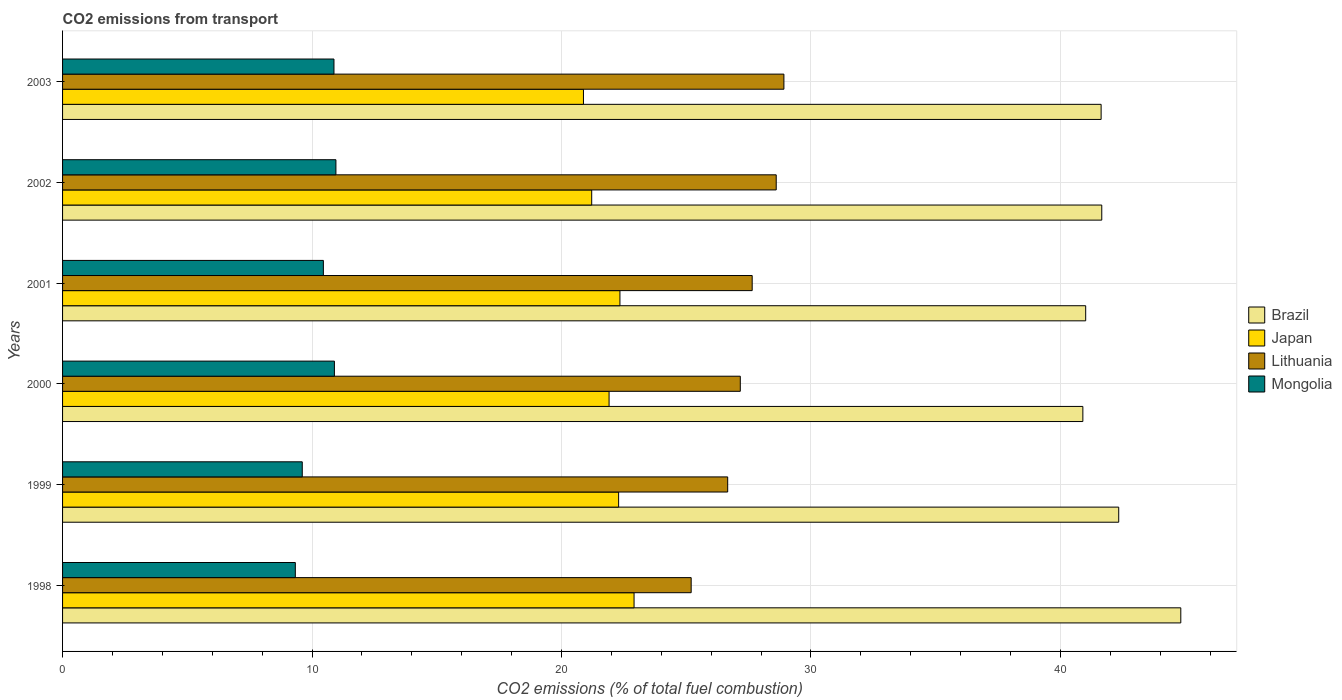How many bars are there on the 6th tick from the bottom?
Provide a short and direct response. 4. What is the total CO2 emitted in Japan in 2001?
Your response must be concise. 22.34. Across all years, what is the maximum total CO2 emitted in Brazil?
Ensure brevity in your answer.  44.82. Across all years, what is the minimum total CO2 emitted in Japan?
Offer a very short reply. 20.88. In which year was the total CO2 emitted in Brazil maximum?
Offer a very short reply. 1998. In which year was the total CO2 emitted in Japan minimum?
Make the answer very short. 2003. What is the total total CO2 emitted in Lithuania in the graph?
Provide a succinct answer. 164.19. What is the difference between the total CO2 emitted in Japan in 2000 and that in 2001?
Offer a very short reply. -0.44. What is the difference between the total CO2 emitted in Brazil in 2000 and the total CO2 emitted in Japan in 1999?
Offer a very short reply. 18.61. What is the average total CO2 emitted in Lithuania per year?
Ensure brevity in your answer.  27.37. In the year 1999, what is the difference between the total CO2 emitted in Mongolia and total CO2 emitted in Japan?
Ensure brevity in your answer.  -12.68. What is the ratio of the total CO2 emitted in Brazil in 1998 to that in 2000?
Provide a short and direct response. 1.1. Is the total CO2 emitted in Japan in 2000 less than that in 2002?
Ensure brevity in your answer.  No. What is the difference between the highest and the second highest total CO2 emitted in Lithuania?
Ensure brevity in your answer.  0.31. What is the difference between the highest and the lowest total CO2 emitted in Japan?
Your response must be concise. 2.03. In how many years, is the total CO2 emitted in Lithuania greater than the average total CO2 emitted in Lithuania taken over all years?
Your answer should be compact. 3. What does the 3rd bar from the top in 2003 represents?
Offer a very short reply. Japan. What does the 2nd bar from the bottom in 2003 represents?
Offer a very short reply. Japan. Is it the case that in every year, the sum of the total CO2 emitted in Lithuania and total CO2 emitted in Japan is greater than the total CO2 emitted in Mongolia?
Your response must be concise. Yes. Are the values on the major ticks of X-axis written in scientific E-notation?
Your answer should be compact. No. Where does the legend appear in the graph?
Your response must be concise. Center right. How are the legend labels stacked?
Your answer should be very brief. Vertical. What is the title of the graph?
Provide a succinct answer. CO2 emissions from transport. What is the label or title of the X-axis?
Your answer should be very brief. CO2 emissions (% of total fuel combustion). What is the CO2 emissions (% of total fuel combustion) of Brazil in 1998?
Your response must be concise. 44.82. What is the CO2 emissions (% of total fuel combustion) in Japan in 1998?
Your response must be concise. 22.91. What is the CO2 emissions (% of total fuel combustion) in Lithuania in 1998?
Your response must be concise. 25.2. What is the CO2 emissions (% of total fuel combustion) of Mongolia in 1998?
Your response must be concise. 9.33. What is the CO2 emissions (% of total fuel combustion) of Brazil in 1999?
Your response must be concise. 42.34. What is the CO2 emissions (% of total fuel combustion) of Japan in 1999?
Your answer should be compact. 22.29. What is the CO2 emissions (% of total fuel combustion) in Lithuania in 1999?
Your answer should be very brief. 26.66. What is the CO2 emissions (% of total fuel combustion) of Mongolia in 1999?
Make the answer very short. 9.61. What is the CO2 emissions (% of total fuel combustion) of Brazil in 2000?
Make the answer very short. 40.9. What is the CO2 emissions (% of total fuel combustion) in Japan in 2000?
Provide a succinct answer. 21.91. What is the CO2 emissions (% of total fuel combustion) in Lithuania in 2000?
Your answer should be very brief. 27.17. What is the CO2 emissions (% of total fuel combustion) of Mongolia in 2000?
Ensure brevity in your answer.  10.9. What is the CO2 emissions (% of total fuel combustion) of Brazil in 2001?
Provide a succinct answer. 41.01. What is the CO2 emissions (% of total fuel combustion) of Japan in 2001?
Your answer should be compact. 22.34. What is the CO2 emissions (% of total fuel combustion) of Lithuania in 2001?
Provide a succinct answer. 27.64. What is the CO2 emissions (% of total fuel combustion) of Mongolia in 2001?
Offer a terse response. 10.45. What is the CO2 emissions (% of total fuel combustion) in Brazil in 2002?
Your response must be concise. 41.66. What is the CO2 emissions (% of total fuel combustion) in Japan in 2002?
Your response must be concise. 21.21. What is the CO2 emissions (% of total fuel combustion) of Lithuania in 2002?
Your answer should be compact. 28.61. What is the CO2 emissions (% of total fuel combustion) in Mongolia in 2002?
Give a very brief answer. 10.96. What is the CO2 emissions (% of total fuel combustion) of Brazil in 2003?
Provide a succinct answer. 41.63. What is the CO2 emissions (% of total fuel combustion) in Japan in 2003?
Keep it short and to the point. 20.88. What is the CO2 emissions (% of total fuel combustion) of Lithuania in 2003?
Provide a succinct answer. 28.91. What is the CO2 emissions (% of total fuel combustion) of Mongolia in 2003?
Give a very brief answer. 10.88. Across all years, what is the maximum CO2 emissions (% of total fuel combustion) of Brazil?
Your response must be concise. 44.82. Across all years, what is the maximum CO2 emissions (% of total fuel combustion) of Japan?
Make the answer very short. 22.91. Across all years, what is the maximum CO2 emissions (% of total fuel combustion) of Lithuania?
Provide a short and direct response. 28.91. Across all years, what is the maximum CO2 emissions (% of total fuel combustion) of Mongolia?
Ensure brevity in your answer.  10.96. Across all years, what is the minimum CO2 emissions (% of total fuel combustion) in Brazil?
Offer a very short reply. 40.9. Across all years, what is the minimum CO2 emissions (% of total fuel combustion) of Japan?
Provide a succinct answer. 20.88. Across all years, what is the minimum CO2 emissions (% of total fuel combustion) in Lithuania?
Make the answer very short. 25.2. Across all years, what is the minimum CO2 emissions (% of total fuel combustion) in Mongolia?
Provide a succinct answer. 9.33. What is the total CO2 emissions (% of total fuel combustion) in Brazil in the graph?
Keep it short and to the point. 252.36. What is the total CO2 emissions (% of total fuel combustion) in Japan in the graph?
Make the answer very short. 131.54. What is the total CO2 emissions (% of total fuel combustion) in Lithuania in the graph?
Make the answer very short. 164.19. What is the total CO2 emissions (% of total fuel combustion) in Mongolia in the graph?
Ensure brevity in your answer.  62.13. What is the difference between the CO2 emissions (% of total fuel combustion) in Brazil in 1998 and that in 1999?
Make the answer very short. 2.49. What is the difference between the CO2 emissions (% of total fuel combustion) of Japan in 1998 and that in 1999?
Your answer should be compact. 0.62. What is the difference between the CO2 emissions (% of total fuel combustion) of Lithuania in 1998 and that in 1999?
Keep it short and to the point. -1.46. What is the difference between the CO2 emissions (% of total fuel combustion) in Mongolia in 1998 and that in 1999?
Give a very brief answer. -0.28. What is the difference between the CO2 emissions (% of total fuel combustion) in Brazil in 1998 and that in 2000?
Keep it short and to the point. 3.93. What is the difference between the CO2 emissions (% of total fuel combustion) in Japan in 1998 and that in 2000?
Ensure brevity in your answer.  1. What is the difference between the CO2 emissions (% of total fuel combustion) of Lithuania in 1998 and that in 2000?
Your answer should be very brief. -1.97. What is the difference between the CO2 emissions (% of total fuel combustion) of Mongolia in 1998 and that in 2000?
Ensure brevity in your answer.  -1.57. What is the difference between the CO2 emissions (% of total fuel combustion) in Brazil in 1998 and that in 2001?
Make the answer very short. 3.81. What is the difference between the CO2 emissions (% of total fuel combustion) of Japan in 1998 and that in 2001?
Keep it short and to the point. 0.57. What is the difference between the CO2 emissions (% of total fuel combustion) in Lithuania in 1998 and that in 2001?
Provide a short and direct response. -2.45. What is the difference between the CO2 emissions (% of total fuel combustion) of Mongolia in 1998 and that in 2001?
Provide a succinct answer. -1.12. What is the difference between the CO2 emissions (% of total fuel combustion) in Brazil in 1998 and that in 2002?
Your response must be concise. 3.17. What is the difference between the CO2 emissions (% of total fuel combustion) in Japan in 1998 and that in 2002?
Offer a terse response. 1.7. What is the difference between the CO2 emissions (% of total fuel combustion) in Lithuania in 1998 and that in 2002?
Keep it short and to the point. -3.41. What is the difference between the CO2 emissions (% of total fuel combustion) of Mongolia in 1998 and that in 2002?
Keep it short and to the point. -1.63. What is the difference between the CO2 emissions (% of total fuel combustion) in Brazil in 1998 and that in 2003?
Provide a succinct answer. 3.19. What is the difference between the CO2 emissions (% of total fuel combustion) in Japan in 1998 and that in 2003?
Provide a succinct answer. 2.03. What is the difference between the CO2 emissions (% of total fuel combustion) in Lithuania in 1998 and that in 2003?
Make the answer very short. -3.72. What is the difference between the CO2 emissions (% of total fuel combustion) in Mongolia in 1998 and that in 2003?
Offer a very short reply. -1.55. What is the difference between the CO2 emissions (% of total fuel combustion) of Brazil in 1999 and that in 2000?
Offer a terse response. 1.44. What is the difference between the CO2 emissions (% of total fuel combustion) of Japan in 1999 and that in 2000?
Keep it short and to the point. 0.38. What is the difference between the CO2 emissions (% of total fuel combustion) in Lithuania in 1999 and that in 2000?
Make the answer very short. -0.51. What is the difference between the CO2 emissions (% of total fuel combustion) of Mongolia in 1999 and that in 2000?
Provide a short and direct response. -1.29. What is the difference between the CO2 emissions (% of total fuel combustion) in Brazil in 1999 and that in 2001?
Provide a short and direct response. 1.32. What is the difference between the CO2 emissions (% of total fuel combustion) in Japan in 1999 and that in 2001?
Make the answer very short. -0.05. What is the difference between the CO2 emissions (% of total fuel combustion) in Lithuania in 1999 and that in 2001?
Provide a succinct answer. -0.98. What is the difference between the CO2 emissions (% of total fuel combustion) of Mongolia in 1999 and that in 2001?
Keep it short and to the point. -0.85. What is the difference between the CO2 emissions (% of total fuel combustion) in Brazil in 1999 and that in 2002?
Your answer should be very brief. 0.68. What is the difference between the CO2 emissions (% of total fuel combustion) of Japan in 1999 and that in 2002?
Your response must be concise. 1.08. What is the difference between the CO2 emissions (% of total fuel combustion) of Lithuania in 1999 and that in 2002?
Ensure brevity in your answer.  -1.95. What is the difference between the CO2 emissions (% of total fuel combustion) of Mongolia in 1999 and that in 2002?
Your response must be concise. -1.35. What is the difference between the CO2 emissions (% of total fuel combustion) in Brazil in 1999 and that in 2003?
Your answer should be very brief. 0.71. What is the difference between the CO2 emissions (% of total fuel combustion) in Japan in 1999 and that in 2003?
Provide a short and direct response. 1.41. What is the difference between the CO2 emissions (% of total fuel combustion) of Lithuania in 1999 and that in 2003?
Keep it short and to the point. -2.25. What is the difference between the CO2 emissions (% of total fuel combustion) in Mongolia in 1999 and that in 2003?
Keep it short and to the point. -1.27. What is the difference between the CO2 emissions (% of total fuel combustion) of Brazil in 2000 and that in 2001?
Provide a short and direct response. -0.11. What is the difference between the CO2 emissions (% of total fuel combustion) in Japan in 2000 and that in 2001?
Give a very brief answer. -0.44. What is the difference between the CO2 emissions (% of total fuel combustion) of Lithuania in 2000 and that in 2001?
Your answer should be very brief. -0.48. What is the difference between the CO2 emissions (% of total fuel combustion) of Mongolia in 2000 and that in 2001?
Provide a short and direct response. 0.44. What is the difference between the CO2 emissions (% of total fuel combustion) of Brazil in 2000 and that in 2002?
Offer a very short reply. -0.76. What is the difference between the CO2 emissions (% of total fuel combustion) of Japan in 2000 and that in 2002?
Offer a very short reply. 0.7. What is the difference between the CO2 emissions (% of total fuel combustion) of Lithuania in 2000 and that in 2002?
Your answer should be compact. -1.44. What is the difference between the CO2 emissions (% of total fuel combustion) in Mongolia in 2000 and that in 2002?
Provide a short and direct response. -0.06. What is the difference between the CO2 emissions (% of total fuel combustion) of Brazil in 2000 and that in 2003?
Offer a very short reply. -0.73. What is the difference between the CO2 emissions (% of total fuel combustion) of Lithuania in 2000 and that in 2003?
Provide a short and direct response. -1.75. What is the difference between the CO2 emissions (% of total fuel combustion) of Mongolia in 2000 and that in 2003?
Ensure brevity in your answer.  0.02. What is the difference between the CO2 emissions (% of total fuel combustion) of Brazil in 2001 and that in 2002?
Keep it short and to the point. -0.64. What is the difference between the CO2 emissions (% of total fuel combustion) of Japan in 2001 and that in 2002?
Your answer should be very brief. 1.13. What is the difference between the CO2 emissions (% of total fuel combustion) of Lithuania in 2001 and that in 2002?
Your answer should be very brief. -0.96. What is the difference between the CO2 emissions (% of total fuel combustion) of Mongolia in 2001 and that in 2002?
Offer a very short reply. -0.5. What is the difference between the CO2 emissions (% of total fuel combustion) of Brazil in 2001 and that in 2003?
Offer a terse response. -0.62. What is the difference between the CO2 emissions (% of total fuel combustion) in Japan in 2001 and that in 2003?
Offer a very short reply. 1.46. What is the difference between the CO2 emissions (% of total fuel combustion) of Lithuania in 2001 and that in 2003?
Your answer should be very brief. -1.27. What is the difference between the CO2 emissions (% of total fuel combustion) in Mongolia in 2001 and that in 2003?
Keep it short and to the point. -0.42. What is the difference between the CO2 emissions (% of total fuel combustion) of Brazil in 2002 and that in 2003?
Provide a succinct answer. 0.03. What is the difference between the CO2 emissions (% of total fuel combustion) in Japan in 2002 and that in 2003?
Your answer should be very brief. 0.33. What is the difference between the CO2 emissions (% of total fuel combustion) in Lithuania in 2002 and that in 2003?
Offer a very short reply. -0.31. What is the difference between the CO2 emissions (% of total fuel combustion) of Mongolia in 2002 and that in 2003?
Offer a terse response. 0.08. What is the difference between the CO2 emissions (% of total fuel combustion) in Brazil in 1998 and the CO2 emissions (% of total fuel combustion) in Japan in 1999?
Make the answer very short. 22.53. What is the difference between the CO2 emissions (% of total fuel combustion) of Brazil in 1998 and the CO2 emissions (% of total fuel combustion) of Lithuania in 1999?
Offer a very short reply. 18.16. What is the difference between the CO2 emissions (% of total fuel combustion) in Brazil in 1998 and the CO2 emissions (% of total fuel combustion) in Mongolia in 1999?
Ensure brevity in your answer.  35.22. What is the difference between the CO2 emissions (% of total fuel combustion) of Japan in 1998 and the CO2 emissions (% of total fuel combustion) of Lithuania in 1999?
Your answer should be very brief. -3.75. What is the difference between the CO2 emissions (% of total fuel combustion) of Japan in 1998 and the CO2 emissions (% of total fuel combustion) of Mongolia in 1999?
Offer a very short reply. 13.3. What is the difference between the CO2 emissions (% of total fuel combustion) of Lithuania in 1998 and the CO2 emissions (% of total fuel combustion) of Mongolia in 1999?
Ensure brevity in your answer.  15.59. What is the difference between the CO2 emissions (% of total fuel combustion) of Brazil in 1998 and the CO2 emissions (% of total fuel combustion) of Japan in 2000?
Give a very brief answer. 22.92. What is the difference between the CO2 emissions (% of total fuel combustion) in Brazil in 1998 and the CO2 emissions (% of total fuel combustion) in Lithuania in 2000?
Make the answer very short. 17.66. What is the difference between the CO2 emissions (% of total fuel combustion) in Brazil in 1998 and the CO2 emissions (% of total fuel combustion) in Mongolia in 2000?
Ensure brevity in your answer.  33.93. What is the difference between the CO2 emissions (% of total fuel combustion) of Japan in 1998 and the CO2 emissions (% of total fuel combustion) of Lithuania in 2000?
Your response must be concise. -4.26. What is the difference between the CO2 emissions (% of total fuel combustion) in Japan in 1998 and the CO2 emissions (% of total fuel combustion) in Mongolia in 2000?
Your answer should be compact. 12.01. What is the difference between the CO2 emissions (% of total fuel combustion) in Lithuania in 1998 and the CO2 emissions (% of total fuel combustion) in Mongolia in 2000?
Offer a very short reply. 14.3. What is the difference between the CO2 emissions (% of total fuel combustion) in Brazil in 1998 and the CO2 emissions (% of total fuel combustion) in Japan in 2001?
Ensure brevity in your answer.  22.48. What is the difference between the CO2 emissions (% of total fuel combustion) in Brazil in 1998 and the CO2 emissions (% of total fuel combustion) in Lithuania in 2001?
Keep it short and to the point. 17.18. What is the difference between the CO2 emissions (% of total fuel combustion) of Brazil in 1998 and the CO2 emissions (% of total fuel combustion) of Mongolia in 2001?
Provide a short and direct response. 34.37. What is the difference between the CO2 emissions (% of total fuel combustion) of Japan in 1998 and the CO2 emissions (% of total fuel combustion) of Lithuania in 2001?
Make the answer very short. -4.73. What is the difference between the CO2 emissions (% of total fuel combustion) of Japan in 1998 and the CO2 emissions (% of total fuel combustion) of Mongolia in 2001?
Provide a succinct answer. 12.45. What is the difference between the CO2 emissions (% of total fuel combustion) in Lithuania in 1998 and the CO2 emissions (% of total fuel combustion) in Mongolia in 2001?
Give a very brief answer. 14.74. What is the difference between the CO2 emissions (% of total fuel combustion) in Brazil in 1998 and the CO2 emissions (% of total fuel combustion) in Japan in 2002?
Your response must be concise. 23.61. What is the difference between the CO2 emissions (% of total fuel combustion) of Brazil in 1998 and the CO2 emissions (% of total fuel combustion) of Lithuania in 2002?
Your answer should be very brief. 16.22. What is the difference between the CO2 emissions (% of total fuel combustion) in Brazil in 1998 and the CO2 emissions (% of total fuel combustion) in Mongolia in 2002?
Offer a very short reply. 33.87. What is the difference between the CO2 emissions (% of total fuel combustion) of Japan in 1998 and the CO2 emissions (% of total fuel combustion) of Lithuania in 2002?
Your answer should be compact. -5.7. What is the difference between the CO2 emissions (% of total fuel combustion) in Japan in 1998 and the CO2 emissions (% of total fuel combustion) in Mongolia in 2002?
Provide a short and direct response. 11.95. What is the difference between the CO2 emissions (% of total fuel combustion) of Lithuania in 1998 and the CO2 emissions (% of total fuel combustion) of Mongolia in 2002?
Give a very brief answer. 14.24. What is the difference between the CO2 emissions (% of total fuel combustion) of Brazil in 1998 and the CO2 emissions (% of total fuel combustion) of Japan in 2003?
Provide a succinct answer. 23.94. What is the difference between the CO2 emissions (% of total fuel combustion) of Brazil in 1998 and the CO2 emissions (% of total fuel combustion) of Lithuania in 2003?
Keep it short and to the point. 15.91. What is the difference between the CO2 emissions (% of total fuel combustion) in Brazil in 1998 and the CO2 emissions (% of total fuel combustion) in Mongolia in 2003?
Ensure brevity in your answer.  33.95. What is the difference between the CO2 emissions (% of total fuel combustion) of Japan in 1998 and the CO2 emissions (% of total fuel combustion) of Lithuania in 2003?
Your response must be concise. -6.01. What is the difference between the CO2 emissions (% of total fuel combustion) of Japan in 1998 and the CO2 emissions (% of total fuel combustion) of Mongolia in 2003?
Offer a terse response. 12.03. What is the difference between the CO2 emissions (% of total fuel combustion) of Lithuania in 1998 and the CO2 emissions (% of total fuel combustion) of Mongolia in 2003?
Ensure brevity in your answer.  14.32. What is the difference between the CO2 emissions (% of total fuel combustion) in Brazil in 1999 and the CO2 emissions (% of total fuel combustion) in Japan in 2000?
Your answer should be very brief. 20.43. What is the difference between the CO2 emissions (% of total fuel combustion) of Brazil in 1999 and the CO2 emissions (% of total fuel combustion) of Lithuania in 2000?
Provide a short and direct response. 15.17. What is the difference between the CO2 emissions (% of total fuel combustion) of Brazil in 1999 and the CO2 emissions (% of total fuel combustion) of Mongolia in 2000?
Give a very brief answer. 31.44. What is the difference between the CO2 emissions (% of total fuel combustion) of Japan in 1999 and the CO2 emissions (% of total fuel combustion) of Lithuania in 2000?
Ensure brevity in your answer.  -4.88. What is the difference between the CO2 emissions (% of total fuel combustion) of Japan in 1999 and the CO2 emissions (% of total fuel combustion) of Mongolia in 2000?
Your answer should be very brief. 11.39. What is the difference between the CO2 emissions (% of total fuel combustion) of Lithuania in 1999 and the CO2 emissions (% of total fuel combustion) of Mongolia in 2000?
Keep it short and to the point. 15.76. What is the difference between the CO2 emissions (% of total fuel combustion) in Brazil in 1999 and the CO2 emissions (% of total fuel combustion) in Japan in 2001?
Provide a succinct answer. 19.99. What is the difference between the CO2 emissions (% of total fuel combustion) of Brazil in 1999 and the CO2 emissions (% of total fuel combustion) of Lithuania in 2001?
Provide a short and direct response. 14.69. What is the difference between the CO2 emissions (% of total fuel combustion) of Brazil in 1999 and the CO2 emissions (% of total fuel combustion) of Mongolia in 2001?
Offer a very short reply. 31.88. What is the difference between the CO2 emissions (% of total fuel combustion) in Japan in 1999 and the CO2 emissions (% of total fuel combustion) in Lithuania in 2001?
Provide a succinct answer. -5.35. What is the difference between the CO2 emissions (% of total fuel combustion) in Japan in 1999 and the CO2 emissions (% of total fuel combustion) in Mongolia in 2001?
Make the answer very short. 11.84. What is the difference between the CO2 emissions (% of total fuel combustion) of Lithuania in 1999 and the CO2 emissions (% of total fuel combustion) of Mongolia in 2001?
Keep it short and to the point. 16.21. What is the difference between the CO2 emissions (% of total fuel combustion) of Brazil in 1999 and the CO2 emissions (% of total fuel combustion) of Japan in 2002?
Offer a terse response. 21.13. What is the difference between the CO2 emissions (% of total fuel combustion) of Brazil in 1999 and the CO2 emissions (% of total fuel combustion) of Lithuania in 2002?
Keep it short and to the point. 13.73. What is the difference between the CO2 emissions (% of total fuel combustion) of Brazil in 1999 and the CO2 emissions (% of total fuel combustion) of Mongolia in 2002?
Your response must be concise. 31.38. What is the difference between the CO2 emissions (% of total fuel combustion) of Japan in 1999 and the CO2 emissions (% of total fuel combustion) of Lithuania in 2002?
Your response must be concise. -6.32. What is the difference between the CO2 emissions (% of total fuel combustion) in Japan in 1999 and the CO2 emissions (% of total fuel combustion) in Mongolia in 2002?
Your answer should be very brief. 11.33. What is the difference between the CO2 emissions (% of total fuel combustion) of Lithuania in 1999 and the CO2 emissions (% of total fuel combustion) of Mongolia in 2002?
Make the answer very short. 15.7. What is the difference between the CO2 emissions (% of total fuel combustion) in Brazil in 1999 and the CO2 emissions (% of total fuel combustion) in Japan in 2003?
Your answer should be compact. 21.46. What is the difference between the CO2 emissions (% of total fuel combustion) of Brazil in 1999 and the CO2 emissions (% of total fuel combustion) of Lithuania in 2003?
Keep it short and to the point. 13.42. What is the difference between the CO2 emissions (% of total fuel combustion) of Brazil in 1999 and the CO2 emissions (% of total fuel combustion) of Mongolia in 2003?
Offer a very short reply. 31.46. What is the difference between the CO2 emissions (% of total fuel combustion) of Japan in 1999 and the CO2 emissions (% of total fuel combustion) of Lithuania in 2003?
Give a very brief answer. -6.63. What is the difference between the CO2 emissions (% of total fuel combustion) in Japan in 1999 and the CO2 emissions (% of total fuel combustion) in Mongolia in 2003?
Your answer should be very brief. 11.41. What is the difference between the CO2 emissions (% of total fuel combustion) in Lithuania in 1999 and the CO2 emissions (% of total fuel combustion) in Mongolia in 2003?
Give a very brief answer. 15.78. What is the difference between the CO2 emissions (% of total fuel combustion) in Brazil in 2000 and the CO2 emissions (% of total fuel combustion) in Japan in 2001?
Provide a short and direct response. 18.56. What is the difference between the CO2 emissions (% of total fuel combustion) in Brazil in 2000 and the CO2 emissions (% of total fuel combustion) in Lithuania in 2001?
Keep it short and to the point. 13.26. What is the difference between the CO2 emissions (% of total fuel combustion) in Brazil in 2000 and the CO2 emissions (% of total fuel combustion) in Mongolia in 2001?
Provide a succinct answer. 30.44. What is the difference between the CO2 emissions (% of total fuel combustion) of Japan in 2000 and the CO2 emissions (% of total fuel combustion) of Lithuania in 2001?
Give a very brief answer. -5.74. What is the difference between the CO2 emissions (% of total fuel combustion) of Japan in 2000 and the CO2 emissions (% of total fuel combustion) of Mongolia in 2001?
Your answer should be very brief. 11.45. What is the difference between the CO2 emissions (% of total fuel combustion) in Lithuania in 2000 and the CO2 emissions (% of total fuel combustion) in Mongolia in 2001?
Make the answer very short. 16.71. What is the difference between the CO2 emissions (% of total fuel combustion) of Brazil in 2000 and the CO2 emissions (% of total fuel combustion) of Japan in 2002?
Offer a very short reply. 19.69. What is the difference between the CO2 emissions (% of total fuel combustion) in Brazil in 2000 and the CO2 emissions (% of total fuel combustion) in Lithuania in 2002?
Give a very brief answer. 12.29. What is the difference between the CO2 emissions (% of total fuel combustion) of Brazil in 2000 and the CO2 emissions (% of total fuel combustion) of Mongolia in 2002?
Keep it short and to the point. 29.94. What is the difference between the CO2 emissions (% of total fuel combustion) in Japan in 2000 and the CO2 emissions (% of total fuel combustion) in Lithuania in 2002?
Provide a succinct answer. -6.7. What is the difference between the CO2 emissions (% of total fuel combustion) of Japan in 2000 and the CO2 emissions (% of total fuel combustion) of Mongolia in 2002?
Offer a terse response. 10.95. What is the difference between the CO2 emissions (% of total fuel combustion) in Lithuania in 2000 and the CO2 emissions (% of total fuel combustion) in Mongolia in 2002?
Give a very brief answer. 16.21. What is the difference between the CO2 emissions (% of total fuel combustion) in Brazil in 2000 and the CO2 emissions (% of total fuel combustion) in Japan in 2003?
Offer a very short reply. 20.02. What is the difference between the CO2 emissions (% of total fuel combustion) in Brazil in 2000 and the CO2 emissions (% of total fuel combustion) in Lithuania in 2003?
Offer a terse response. 11.98. What is the difference between the CO2 emissions (% of total fuel combustion) of Brazil in 2000 and the CO2 emissions (% of total fuel combustion) of Mongolia in 2003?
Offer a terse response. 30.02. What is the difference between the CO2 emissions (% of total fuel combustion) in Japan in 2000 and the CO2 emissions (% of total fuel combustion) in Lithuania in 2003?
Keep it short and to the point. -7.01. What is the difference between the CO2 emissions (% of total fuel combustion) of Japan in 2000 and the CO2 emissions (% of total fuel combustion) of Mongolia in 2003?
Ensure brevity in your answer.  11.03. What is the difference between the CO2 emissions (% of total fuel combustion) of Lithuania in 2000 and the CO2 emissions (% of total fuel combustion) of Mongolia in 2003?
Keep it short and to the point. 16.29. What is the difference between the CO2 emissions (% of total fuel combustion) in Brazil in 2001 and the CO2 emissions (% of total fuel combustion) in Japan in 2002?
Offer a terse response. 19.8. What is the difference between the CO2 emissions (% of total fuel combustion) in Brazil in 2001 and the CO2 emissions (% of total fuel combustion) in Lithuania in 2002?
Your answer should be compact. 12.41. What is the difference between the CO2 emissions (% of total fuel combustion) in Brazil in 2001 and the CO2 emissions (% of total fuel combustion) in Mongolia in 2002?
Provide a succinct answer. 30.05. What is the difference between the CO2 emissions (% of total fuel combustion) in Japan in 2001 and the CO2 emissions (% of total fuel combustion) in Lithuania in 2002?
Keep it short and to the point. -6.26. What is the difference between the CO2 emissions (% of total fuel combustion) of Japan in 2001 and the CO2 emissions (% of total fuel combustion) of Mongolia in 2002?
Keep it short and to the point. 11.38. What is the difference between the CO2 emissions (% of total fuel combustion) of Lithuania in 2001 and the CO2 emissions (% of total fuel combustion) of Mongolia in 2002?
Offer a terse response. 16.69. What is the difference between the CO2 emissions (% of total fuel combustion) in Brazil in 2001 and the CO2 emissions (% of total fuel combustion) in Japan in 2003?
Ensure brevity in your answer.  20.13. What is the difference between the CO2 emissions (% of total fuel combustion) in Brazil in 2001 and the CO2 emissions (% of total fuel combustion) in Lithuania in 2003?
Your answer should be very brief. 12.1. What is the difference between the CO2 emissions (% of total fuel combustion) of Brazil in 2001 and the CO2 emissions (% of total fuel combustion) of Mongolia in 2003?
Your response must be concise. 30.13. What is the difference between the CO2 emissions (% of total fuel combustion) in Japan in 2001 and the CO2 emissions (% of total fuel combustion) in Lithuania in 2003?
Keep it short and to the point. -6.57. What is the difference between the CO2 emissions (% of total fuel combustion) in Japan in 2001 and the CO2 emissions (% of total fuel combustion) in Mongolia in 2003?
Your answer should be compact. 11.46. What is the difference between the CO2 emissions (% of total fuel combustion) of Lithuania in 2001 and the CO2 emissions (% of total fuel combustion) of Mongolia in 2003?
Give a very brief answer. 16.76. What is the difference between the CO2 emissions (% of total fuel combustion) in Brazil in 2002 and the CO2 emissions (% of total fuel combustion) in Japan in 2003?
Your response must be concise. 20.78. What is the difference between the CO2 emissions (% of total fuel combustion) of Brazil in 2002 and the CO2 emissions (% of total fuel combustion) of Lithuania in 2003?
Your answer should be compact. 12.74. What is the difference between the CO2 emissions (% of total fuel combustion) of Brazil in 2002 and the CO2 emissions (% of total fuel combustion) of Mongolia in 2003?
Ensure brevity in your answer.  30.78. What is the difference between the CO2 emissions (% of total fuel combustion) of Japan in 2002 and the CO2 emissions (% of total fuel combustion) of Lithuania in 2003?
Make the answer very short. -7.7. What is the difference between the CO2 emissions (% of total fuel combustion) of Japan in 2002 and the CO2 emissions (% of total fuel combustion) of Mongolia in 2003?
Your response must be concise. 10.33. What is the difference between the CO2 emissions (% of total fuel combustion) of Lithuania in 2002 and the CO2 emissions (% of total fuel combustion) of Mongolia in 2003?
Your response must be concise. 17.73. What is the average CO2 emissions (% of total fuel combustion) of Brazil per year?
Your response must be concise. 42.06. What is the average CO2 emissions (% of total fuel combustion) of Japan per year?
Provide a short and direct response. 21.92. What is the average CO2 emissions (% of total fuel combustion) of Lithuania per year?
Ensure brevity in your answer.  27.37. What is the average CO2 emissions (% of total fuel combustion) in Mongolia per year?
Provide a short and direct response. 10.35. In the year 1998, what is the difference between the CO2 emissions (% of total fuel combustion) of Brazil and CO2 emissions (% of total fuel combustion) of Japan?
Your response must be concise. 21.92. In the year 1998, what is the difference between the CO2 emissions (% of total fuel combustion) of Brazil and CO2 emissions (% of total fuel combustion) of Lithuania?
Ensure brevity in your answer.  19.63. In the year 1998, what is the difference between the CO2 emissions (% of total fuel combustion) in Brazil and CO2 emissions (% of total fuel combustion) in Mongolia?
Keep it short and to the point. 35.49. In the year 1998, what is the difference between the CO2 emissions (% of total fuel combustion) in Japan and CO2 emissions (% of total fuel combustion) in Lithuania?
Give a very brief answer. -2.29. In the year 1998, what is the difference between the CO2 emissions (% of total fuel combustion) in Japan and CO2 emissions (% of total fuel combustion) in Mongolia?
Your answer should be very brief. 13.58. In the year 1998, what is the difference between the CO2 emissions (% of total fuel combustion) of Lithuania and CO2 emissions (% of total fuel combustion) of Mongolia?
Offer a very short reply. 15.87. In the year 1999, what is the difference between the CO2 emissions (% of total fuel combustion) of Brazil and CO2 emissions (% of total fuel combustion) of Japan?
Provide a short and direct response. 20.05. In the year 1999, what is the difference between the CO2 emissions (% of total fuel combustion) in Brazil and CO2 emissions (% of total fuel combustion) in Lithuania?
Give a very brief answer. 15.67. In the year 1999, what is the difference between the CO2 emissions (% of total fuel combustion) in Brazil and CO2 emissions (% of total fuel combustion) in Mongolia?
Keep it short and to the point. 32.73. In the year 1999, what is the difference between the CO2 emissions (% of total fuel combustion) of Japan and CO2 emissions (% of total fuel combustion) of Lithuania?
Keep it short and to the point. -4.37. In the year 1999, what is the difference between the CO2 emissions (% of total fuel combustion) of Japan and CO2 emissions (% of total fuel combustion) of Mongolia?
Your response must be concise. 12.68. In the year 1999, what is the difference between the CO2 emissions (% of total fuel combustion) of Lithuania and CO2 emissions (% of total fuel combustion) of Mongolia?
Your answer should be compact. 17.05. In the year 2000, what is the difference between the CO2 emissions (% of total fuel combustion) of Brazil and CO2 emissions (% of total fuel combustion) of Japan?
Provide a succinct answer. 18.99. In the year 2000, what is the difference between the CO2 emissions (% of total fuel combustion) of Brazil and CO2 emissions (% of total fuel combustion) of Lithuania?
Provide a succinct answer. 13.73. In the year 2000, what is the difference between the CO2 emissions (% of total fuel combustion) of Brazil and CO2 emissions (% of total fuel combustion) of Mongolia?
Your answer should be compact. 30. In the year 2000, what is the difference between the CO2 emissions (% of total fuel combustion) of Japan and CO2 emissions (% of total fuel combustion) of Lithuania?
Keep it short and to the point. -5.26. In the year 2000, what is the difference between the CO2 emissions (% of total fuel combustion) of Japan and CO2 emissions (% of total fuel combustion) of Mongolia?
Make the answer very short. 11.01. In the year 2000, what is the difference between the CO2 emissions (% of total fuel combustion) in Lithuania and CO2 emissions (% of total fuel combustion) in Mongolia?
Keep it short and to the point. 16.27. In the year 2001, what is the difference between the CO2 emissions (% of total fuel combustion) in Brazil and CO2 emissions (% of total fuel combustion) in Japan?
Provide a short and direct response. 18.67. In the year 2001, what is the difference between the CO2 emissions (% of total fuel combustion) of Brazil and CO2 emissions (% of total fuel combustion) of Lithuania?
Your answer should be very brief. 13.37. In the year 2001, what is the difference between the CO2 emissions (% of total fuel combustion) of Brazil and CO2 emissions (% of total fuel combustion) of Mongolia?
Keep it short and to the point. 30.56. In the year 2001, what is the difference between the CO2 emissions (% of total fuel combustion) in Japan and CO2 emissions (% of total fuel combustion) in Lithuania?
Keep it short and to the point. -5.3. In the year 2001, what is the difference between the CO2 emissions (% of total fuel combustion) in Japan and CO2 emissions (% of total fuel combustion) in Mongolia?
Your answer should be compact. 11.89. In the year 2001, what is the difference between the CO2 emissions (% of total fuel combustion) of Lithuania and CO2 emissions (% of total fuel combustion) of Mongolia?
Provide a succinct answer. 17.19. In the year 2002, what is the difference between the CO2 emissions (% of total fuel combustion) of Brazil and CO2 emissions (% of total fuel combustion) of Japan?
Your answer should be compact. 20.45. In the year 2002, what is the difference between the CO2 emissions (% of total fuel combustion) of Brazil and CO2 emissions (% of total fuel combustion) of Lithuania?
Your response must be concise. 13.05. In the year 2002, what is the difference between the CO2 emissions (% of total fuel combustion) of Brazil and CO2 emissions (% of total fuel combustion) of Mongolia?
Ensure brevity in your answer.  30.7. In the year 2002, what is the difference between the CO2 emissions (% of total fuel combustion) in Japan and CO2 emissions (% of total fuel combustion) in Lithuania?
Offer a very short reply. -7.4. In the year 2002, what is the difference between the CO2 emissions (% of total fuel combustion) in Japan and CO2 emissions (% of total fuel combustion) in Mongolia?
Provide a succinct answer. 10.25. In the year 2002, what is the difference between the CO2 emissions (% of total fuel combustion) in Lithuania and CO2 emissions (% of total fuel combustion) in Mongolia?
Provide a short and direct response. 17.65. In the year 2003, what is the difference between the CO2 emissions (% of total fuel combustion) of Brazil and CO2 emissions (% of total fuel combustion) of Japan?
Offer a terse response. 20.75. In the year 2003, what is the difference between the CO2 emissions (% of total fuel combustion) in Brazil and CO2 emissions (% of total fuel combustion) in Lithuania?
Give a very brief answer. 12.72. In the year 2003, what is the difference between the CO2 emissions (% of total fuel combustion) of Brazil and CO2 emissions (% of total fuel combustion) of Mongolia?
Keep it short and to the point. 30.75. In the year 2003, what is the difference between the CO2 emissions (% of total fuel combustion) in Japan and CO2 emissions (% of total fuel combustion) in Lithuania?
Provide a short and direct response. -8.03. In the year 2003, what is the difference between the CO2 emissions (% of total fuel combustion) in Japan and CO2 emissions (% of total fuel combustion) in Mongolia?
Your response must be concise. 10. In the year 2003, what is the difference between the CO2 emissions (% of total fuel combustion) in Lithuania and CO2 emissions (% of total fuel combustion) in Mongolia?
Make the answer very short. 18.04. What is the ratio of the CO2 emissions (% of total fuel combustion) of Brazil in 1998 to that in 1999?
Offer a very short reply. 1.06. What is the ratio of the CO2 emissions (% of total fuel combustion) in Japan in 1998 to that in 1999?
Give a very brief answer. 1.03. What is the ratio of the CO2 emissions (% of total fuel combustion) of Lithuania in 1998 to that in 1999?
Your answer should be very brief. 0.95. What is the ratio of the CO2 emissions (% of total fuel combustion) of Mongolia in 1998 to that in 1999?
Offer a terse response. 0.97. What is the ratio of the CO2 emissions (% of total fuel combustion) of Brazil in 1998 to that in 2000?
Ensure brevity in your answer.  1.1. What is the ratio of the CO2 emissions (% of total fuel combustion) of Japan in 1998 to that in 2000?
Provide a short and direct response. 1.05. What is the ratio of the CO2 emissions (% of total fuel combustion) in Lithuania in 1998 to that in 2000?
Ensure brevity in your answer.  0.93. What is the ratio of the CO2 emissions (% of total fuel combustion) in Mongolia in 1998 to that in 2000?
Offer a terse response. 0.86. What is the ratio of the CO2 emissions (% of total fuel combustion) of Brazil in 1998 to that in 2001?
Keep it short and to the point. 1.09. What is the ratio of the CO2 emissions (% of total fuel combustion) in Japan in 1998 to that in 2001?
Your response must be concise. 1.03. What is the ratio of the CO2 emissions (% of total fuel combustion) of Lithuania in 1998 to that in 2001?
Your answer should be very brief. 0.91. What is the ratio of the CO2 emissions (% of total fuel combustion) in Mongolia in 1998 to that in 2001?
Make the answer very short. 0.89. What is the ratio of the CO2 emissions (% of total fuel combustion) in Brazil in 1998 to that in 2002?
Provide a succinct answer. 1.08. What is the ratio of the CO2 emissions (% of total fuel combustion) of Japan in 1998 to that in 2002?
Offer a very short reply. 1.08. What is the ratio of the CO2 emissions (% of total fuel combustion) in Lithuania in 1998 to that in 2002?
Provide a short and direct response. 0.88. What is the ratio of the CO2 emissions (% of total fuel combustion) in Mongolia in 1998 to that in 2002?
Your response must be concise. 0.85. What is the ratio of the CO2 emissions (% of total fuel combustion) in Brazil in 1998 to that in 2003?
Your answer should be very brief. 1.08. What is the ratio of the CO2 emissions (% of total fuel combustion) of Japan in 1998 to that in 2003?
Your response must be concise. 1.1. What is the ratio of the CO2 emissions (% of total fuel combustion) of Lithuania in 1998 to that in 2003?
Keep it short and to the point. 0.87. What is the ratio of the CO2 emissions (% of total fuel combustion) in Mongolia in 1998 to that in 2003?
Offer a very short reply. 0.86. What is the ratio of the CO2 emissions (% of total fuel combustion) in Brazil in 1999 to that in 2000?
Give a very brief answer. 1.04. What is the ratio of the CO2 emissions (% of total fuel combustion) of Japan in 1999 to that in 2000?
Keep it short and to the point. 1.02. What is the ratio of the CO2 emissions (% of total fuel combustion) of Lithuania in 1999 to that in 2000?
Give a very brief answer. 0.98. What is the ratio of the CO2 emissions (% of total fuel combustion) of Mongolia in 1999 to that in 2000?
Make the answer very short. 0.88. What is the ratio of the CO2 emissions (% of total fuel combustion) in Brazil in 1999 to that in 2001?
Your response must be concise. 1.03. What is the ratio of the CO2 emissions (% of total fuel combustion) of Japan in 1999 to that in 2001?
Your response must be concise. 1. What is the ratio of the CO2 emissions (% of total fuel combustion) of Lithuania in 1999 to that in 2001?
Provide a succinct answer. 0.96. What is the ratio of the CO2 emissions (% of total fuel combustion) of Mongolia in 1999 to that in 2001?
Your answer should be compact. 0.92. What is the ratio of the CO2 emissions (% of total fuel combustion) in Brazil in 1999 to that in 2002?
Give a very brief answer. 1.02. What is the ratio of the CO2 emissions (% of total fuel combustion) in Japan in 1999 to that in 2002?
Provide a short and direct response. 1.05. What is the ratio of the CO2 emissions (% of total fuel combustion) of Lithuania in 1999 to that in 2002?
Provide a short and direct response. 0.93. What is the ratio of the CO2 emissions (% of total fuel combustion) of Mongolia in 1999 to that in 2002?
Your response must be concise. 0.88. What is the ratio of the CO2 emissions (% of total fuel combustion) in Brazil in 1999 to that in 2003?
Offer a very short reply. 1.02. What is the ratio of the CO2 emissions (% of total fuel combustion) of Japan in 1999 to that in 2003?
Make the answer very short. 1.07. What is the ratio of the CO2 emissions (% of total fuel combustion) in Lithuania in 1999 to that in 2003?
Make the answer very short. 0.92. What is the ratio of the CO2 emissions (% of total fuel combustion) in Mongolia in 1999 to that in 2003?
Offer a very short reply. 0.88. What is the ratio of the CO2 emissions (% of total fuel combustion) of Brazil in 2000 to that in 2001?
Your response must be concise. 1. What is the ratio of the CO2 emissions (% of total fuel combustion) of Japan in 2000 to that in 2001?
Your answer should be very brief. 0.98. What is the ratio of the CO2 emissions (% of total fuel combustion) of Lithuania in 2000 to that in 2001?
Make the answer very short. 0.98. What is the ratio of the CO2 emissions (% of total fuel combustion) in Mongolia in 2000 to that in 2001?
Keep it short and to the point. 1.04. What is the ratio of the CO2 emissions (% of total fuel combustion) of Brazil in 2000 to that in 2002?
Offer a very short reply. 0.98. What is the ratio of the CO2 emissions (% of total fuel combustion) in Japan in 2000 to that in 2002?
Offer a terse response. 1.03. What is the ratio of the CO2 emissions (% of total fuel combustion) of Lithuania in 2000 to that in 2002?
Ensure brevity in your answer.  0.95. What is the ratio of the CO2 emissions (% of total fuel combustion) in Mongolia in 2000 to that in 2002?
Provide a short and direct response. 0.99. What is the ratio of the CO2 emissions (% of total fuel combustion) in Brazil in 2000 to that in 2003?
Make the answer very short. 0.98. What is the ratio of the CO2 emissions (% of total fuel combustion) in Japan in 2000 to that in 2003?
Your answer should be very brief. 1.05. What is the ratio of the CO2 emissions (% of total fuel combustion) of Lithuania in 2000 to that in 2003?
Offer a terse response. 0.94. What is the ratio of the CO2 emissions (% of total fuel combustion) in Brazil in 2001 to that in 2002?
Make the answer very short. 0.98. What is the ratio of the CO2 emissions (% of total fuel combustion) of Japan in 2001 to that in 2002?
Give a very brief answer. 1.05. What is the ratio of the CO2 emissions (% of total fuel combustion) of Lithuania in 2001 to that in 2002?
Provide a short and direct response. 0.97. What is the ratio of the CO2 emissions (% of total fuel combustion) in Mongolia in 2001 to that in 2002?
Keep it short and to the point. 0.95. What is the ratio of the CO2 emissions (% of total fuel combustion) in Brazil in 2001 to that in 2003?
Provide a short and direct response. 0.99. What is the ratio of the CO2 emissions (% of total fuel combustion) of Japan in 2001 to that in 2003?
Your answer should be compact. 1.07. What is the ratio of the CO2 emissions (% of total fuel combustion) in Lithuania in 2001 to that in 2003?
Provide a short and direct response. 0.96. What is the ratio of the CO2 emissions (% of total fuel combustion) in Mongolia in 2001 to that in 2003?
Keep it short and to the point. 0.96. What is the ratio of the CO2 emissions (% of total fuel combustion) of Japan in 2002 to that in 2003?
Your answer should be compact. 1.02. What is the difference between the highest and the second highest CO2 emissions (% of total fuel combustion) of Brazil?
Your answer should be compact. 2.49. What is the difference between the highest and the second highest CO2 emissions (% of total fuel combustion) of Japan?
Provide a short and direct response. 0.57. What is the difference between the highest and the second highest CO2 emissions (% of total fuel combustion) in Lithuania?
Give a very brief answer. 0.31. What is the difference between the highest and the second highest CO2 emissions (% of total fuel combustion) in Mongolia?
Keep it short and to the point. 0.06. What is the difference between the highest and the lowest CO2 emissions (% of total fuel combustion) of Brazil?
Your answer should be compact. 3.93. What is the difference between the highest and the lowest CO2 emissions (% of total fuel combustion) of Japan?
Your answer should be compact. 2.03. What is the difference between the highest and the lowest CO2 emissions (% of total fuel combustion) in Lithuania?
Offer a terse response. 3.72. What is the difference between the highest and the lowest CO2 emissions (% of total fuel combustion) of Mongolia?
Offer a very short reply. 1.63. 